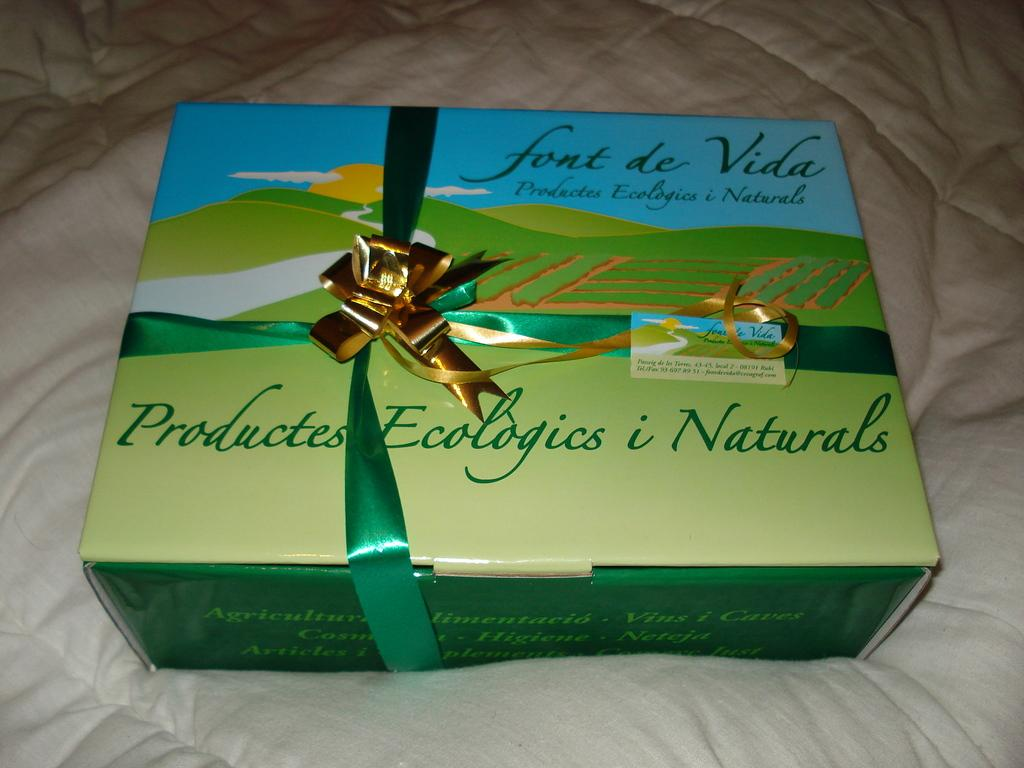<image>
Write a terse but informative summary of the picture. A box of font de Vida, containing natural products sits on a bed. 